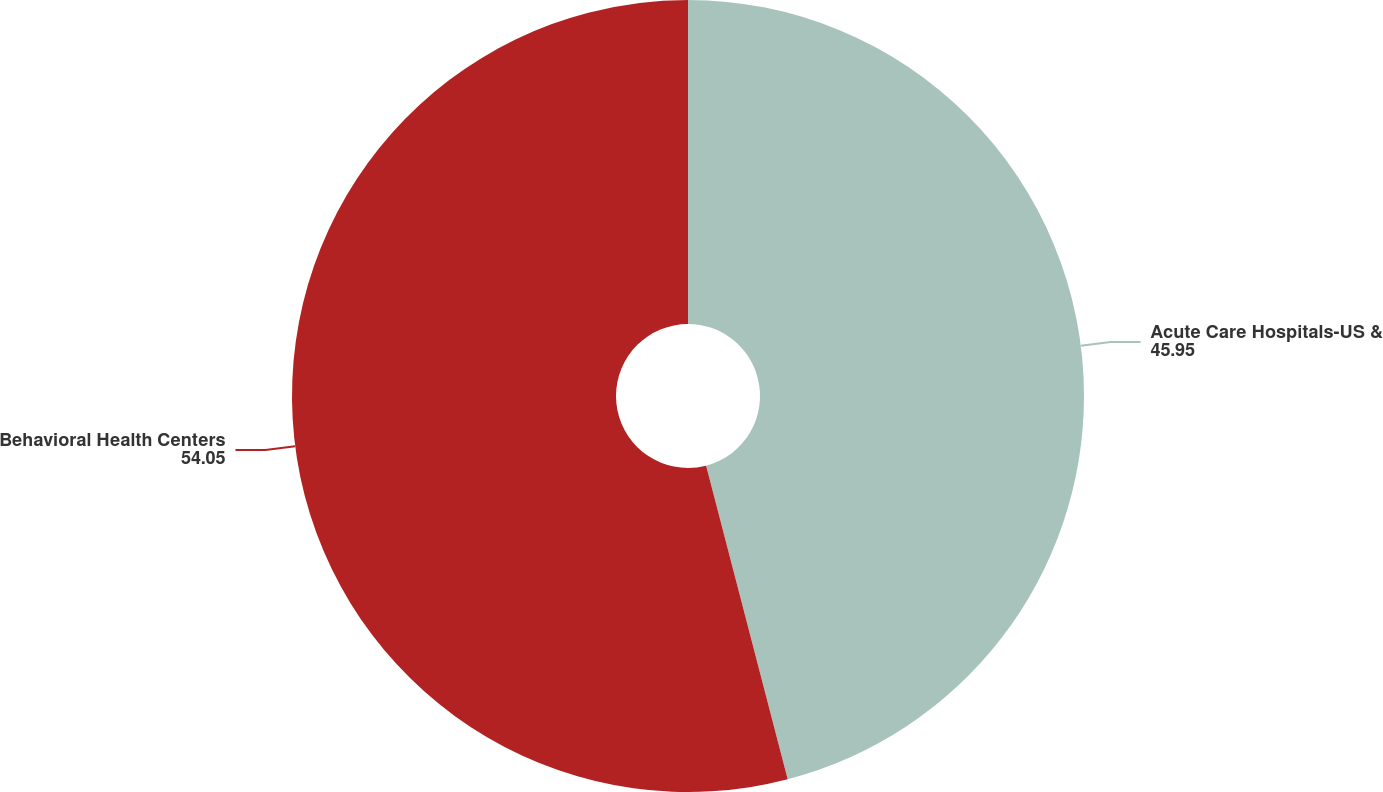<chart> <loc_0><loc_0><loc_500><loc_500><pie_chart><fcel>Acute Care Hospitals-US &<fcel>Behavioral Health Centers<nl><fcel>45.95%<fcel>54.05%<nl></chart> 